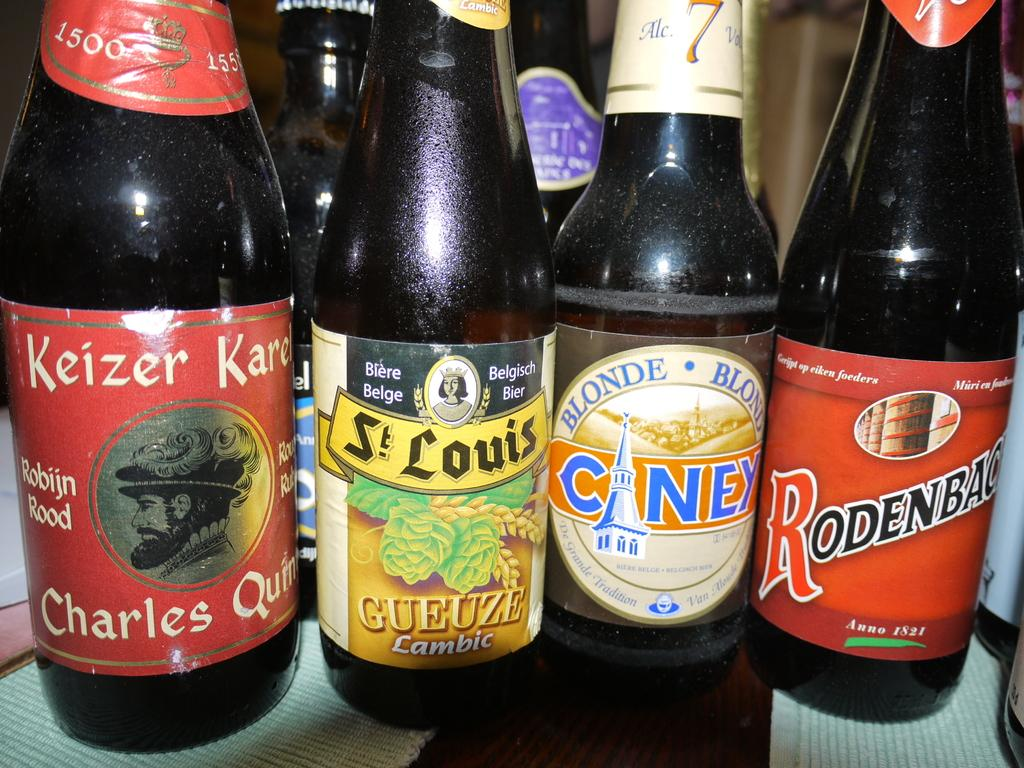<image>
Relay a brief, clear account of the picture shown. A bottle of St Louis brand beer is displayed alongside several other brands of beer. 